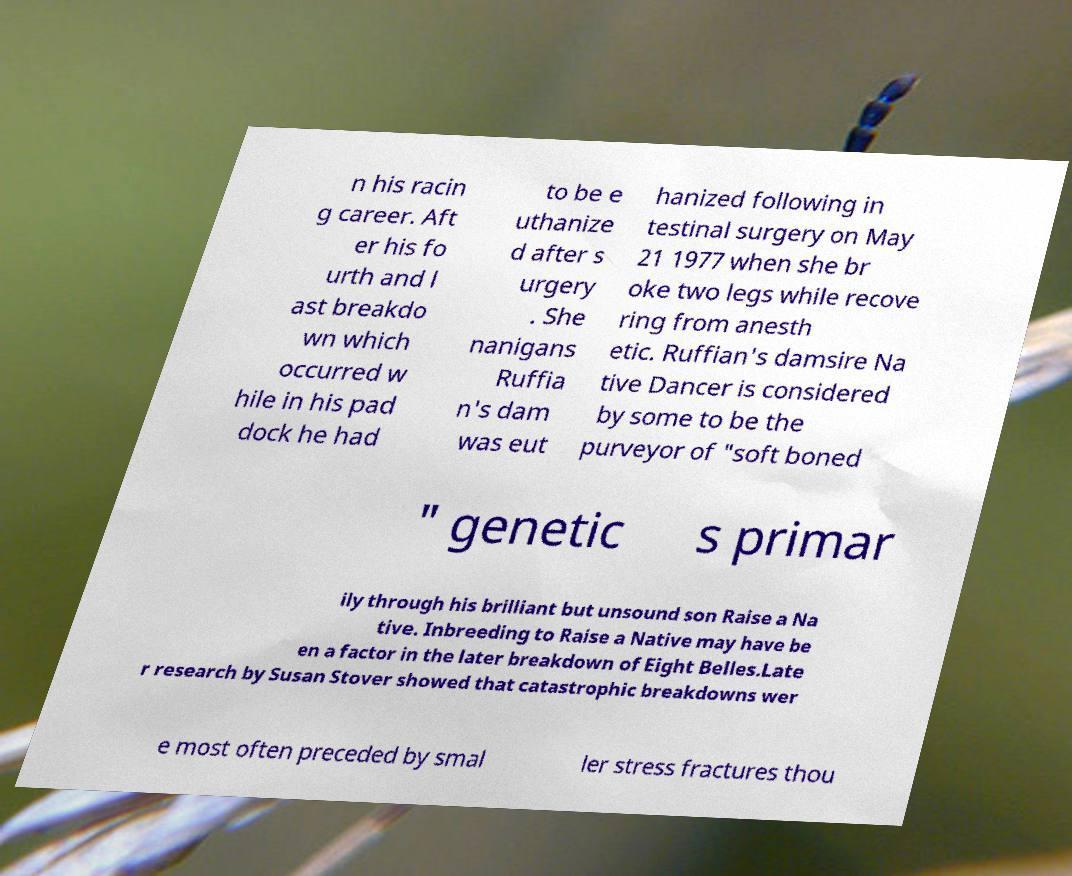I need the written content from this picture converted into text. Can you do that? n his racin g career. Aft er his fo urth and l ast breakdo wn which occurred w hile in his pad dock he had to be e uthanize d after s urgery . She nanigans Ruffia n's dam was eut hanized following in testinal surgery on May 21 1977 when she br oke two legs while recove ring from anesth etic. Ruffian's damsire Na tive Dancer is considered by some to be the purveyor of "soft boned " genetic s primar ily through his brilliant but unsound son Raise a Na tive. Inbreeding to Raise a Native may have be en a factor in the later breakdown of Eight Belles.Late r research by Susan Stover showed that catastrophic breakdowns wer e most often preceded by smal ler stress fractures thou 